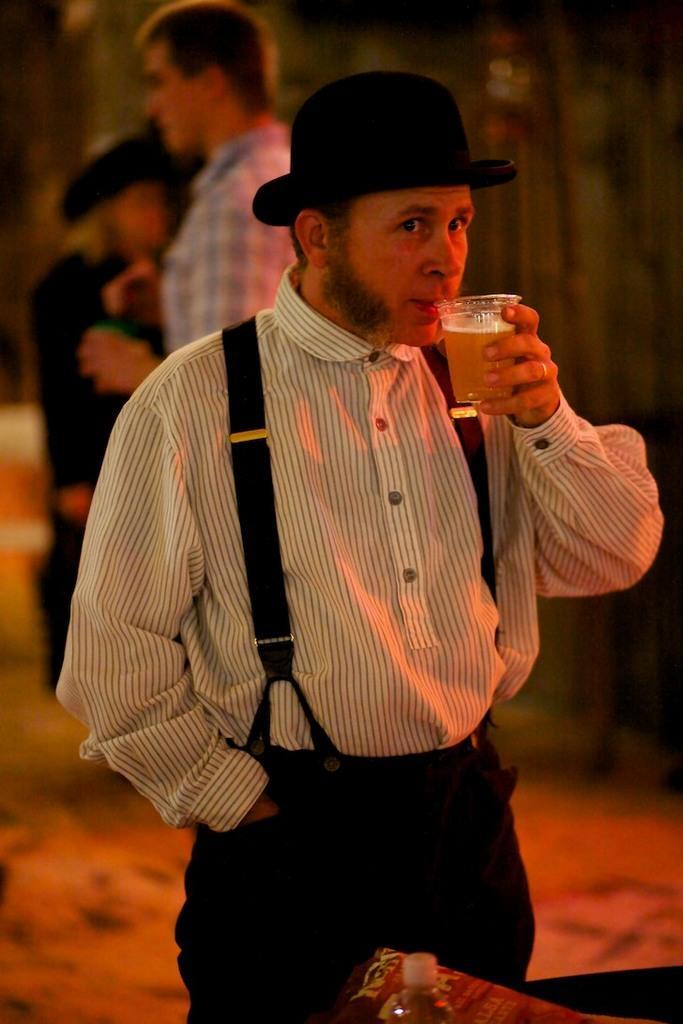Could you give a brief overview of what you see in this image? In this image we can see a man wearing the black color hat and holding the glass of liquid and drinking. In the background we can also see two persons. At the bottom there is water bottle. 